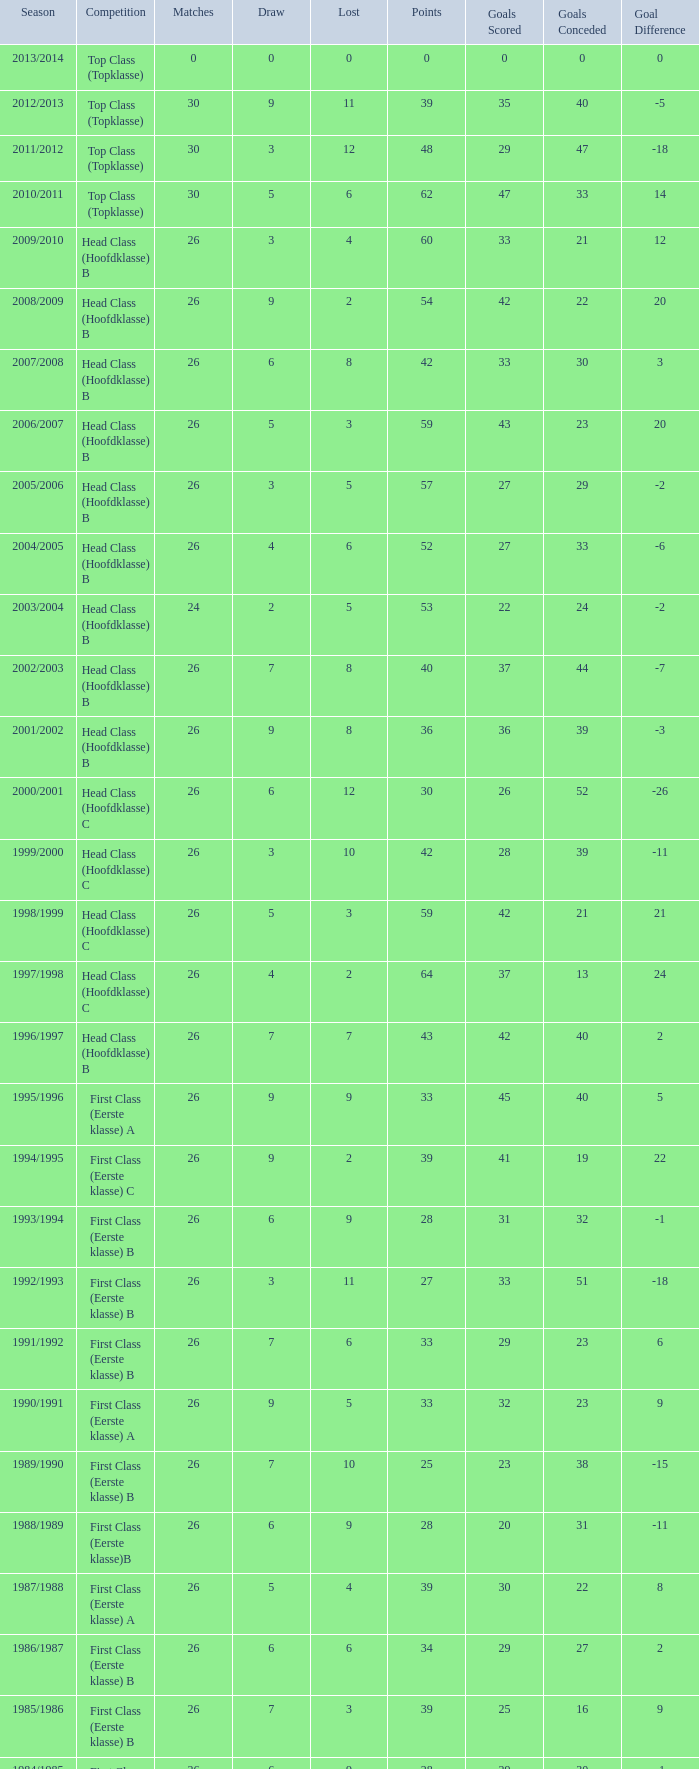What competition has a score greater than 30, a draw less than 5, and a loss larger than 10? Top Class (Topklasse). 